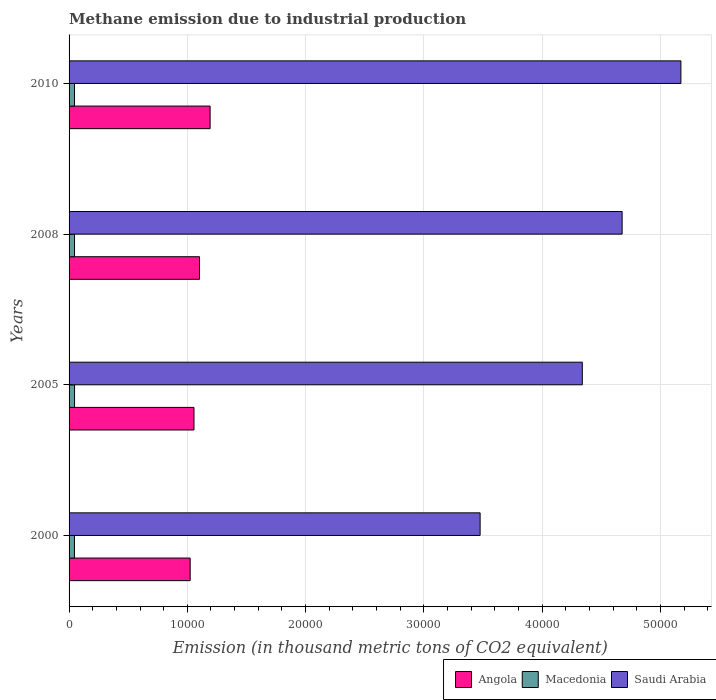How many different coloured bars are there?
Ensure brevity in your answer.  3. Are the number of bars per tick equal to the number of legend labels?
Give a very brief answer. Yes. Are the number of bars on each tick of the Y-axis equal?
Make the answer very short. Yes. What is the amount of methane emitted in Saudi Arabia in 2008?
Your answer should be compact. 4.68e+04. Across all years, what is the maximum amount of methane emitted in Macedonia?
Your answer should be compact. 464.2. Across all years, what is the minimum amount of methane emitted in Angola?
Give a very brief answer. 1.02e+04. In which year was the amount of methane emitted in Saudi Arabia minimum?
Offer a terse response. 2000. What is the total amount of methane emitted in Macedonia in the graph?
Ensure brevity in your answer.  1840.8. What is the difference between the amount of methane emitted in Saudi Arabia in 2000 and that in 2008?
Make the answer very short. -1.20e+04. What is the difference between the amount of methane emitted in Saudi Arabia in 2010 and the amount of methane emitted in Macedonia in 2000?
Provide a short and direct response. 5.13e+04. What is the average amount of methane emitted in Saudi Arabia per year?
Your answer should be very brief. 4.42e+04. In the year 2005, what is the difference between the amount of methane emitted in Angola and amount of methane emitted in Saudi Arabia?
Offer a very short reply. -3.28e+04. What is the ratio of the amount of methane emitted in Angola in 2005 to that in 2010?
Your answer should be very brief. 0.89. Is the difference between the amount of methane emitted in Angola in 2000 and 2008 greater than the difference between the amount of methane emitted in Saudi Arabia in 2000 and 2008?
Offer a terse response. Yes. What is the difference between the highest and the second highest amount of methane emitted in Angola?
Your answer should be compact. 894.1. What is the difference between the highest and the lowest amount of methane emitted in Saudi Arabia?
Provide a succinct answer. 1.70e+04. In how many years, is the amount of methane emitted in Macedonia greater than the average amount of methane emitted in Macedonia taken over all years?
Make the answer very short. 2. What does the 3rd bar from the top in 2005 represents?
Offer a terse response. Angola. What does the 1st bar from the bottom in 2000 represents?
Your answer should be compact. Angola. What is the difference between two consecutive major ticks on the X-axis?
Ensure brevity in your answer.  10000. Does the graph contain any zero values?
Give a very brief answer. No. Does the graph contain grids?
Provide a succinct answer. Yes. Where does the legend appear in the graph?
Keep it short and to the point. Bottom right. How are the legend labels stacked?
Your answer should be compact. Horizontal. What is the title of the graph?
Offer a very short reply. Methane emission due to industrial production. Does "Colombia" appear as one of the legend labels in the graph?
Ensure brevity in your answer.  No. What is the label or title of the X-axis?
Make the answer very short. Emission (in thousand metric tons of CO2 equivalent). What is the Emission (in thousand metric tons of CO2 equivalent) of Angola in 2000?
Offer a very short reply. 1.02e+04. What is the Emission (in thousand metric tons of CO2 equivalent) in Macedonia in 2000?
Your answer should be compact. 454.8. What is the Emission (in thousand metric tons of CO2 equivalent) in Saudi Arabia in 2000?
Offer a very short reply. 3.48e+04. What is the Emission (in thousand metric tons of CO2 equivalent) in Angola in 2005?
Your response must be concise. 1.06e+04. What is the Emission (in thousand metric tons of CO2 equivalent) in Macedonia in 2005?
Your answer should be very brief. 464.2. What is the Emission (in thousand metric tons of CO2 equivalent) in Saudi Arabia in 2005?
Your response must be concise. 4.34e+04. What is the Emission (in thousand metric tons of CO2 equivalent) of Angola in 2008?
Make the answer very short. 1.10e+04. What is the Emission (in thousand metric tons of CO2 equivalent) in Macedonia in 2008?
Your answer should be very brief. 461.8. What is the Emission (in thousand metric tons of CO2 equivalent) in Saudi Arabia in 2008?
Provide a succinct answer. 4.68e+04. What is the Emission (in thousand metric tons of CO2 equivalent) in Angola in 2010?
Offer a very short reply. 1.19e+04. What is the Emission (in thousand metric tons of CO2 equivalent) of Macedonia in 2010?
Make the answer very short. 460. What is the Emission (in thousand metric tons of CO2 equivalent) in Saudi Arabia in 2010?
Your answer should be very brief. 5.17e+04. Across all years, what is the maximum Emission (in thousand metric tons of CO2 equivalent) of Angola?
Give a very brief answer. 1.19e+04. Across all years, what is the maximum Emission (in thousand metric tons of CO2 equivalent) of Macedonia?
Offer a terse response. 464.2. Across all years, what is the maximum Emission (in thousand metric tons of CO2 equivalent) of Saudi Arabia?
Give a very brief answer. 5.17e+04. Across all years, what is the minimum Emission (in thousand metric tons of CO2 equivalent) in Angola?
Your answer should be compact. 1.02e+04. Across all years, what is the minimum Emission (in thousand metric tons of CO2 equivalent) of Macedonia?
Your answer should be very brief. 454.8. Across all years, what is the minimum Emission (in thousand metric tons of CO2 equivalent) in Saudi Arabia?
Give a very brief answer. 3.48e+04. What is the total Emission (in thousand metric tons of CO2 equivalent) in Angola in the graph?
Ensure brevity in your answer.  4.38e+04. What is the total Emission (in thousand metric tons of CO2 equivalent) of Macedonia in the graph?
Keep it short and to the point. 1840.8. What is the total Emission (in thousand metric tons of CO2 equivalent) in Saudi Arabia in the graph?
Your answer should be compact. 1.77e+05. What is the difference between the Emission (in thousand metric tons of CO2 equivalent) in Angola in 2000 and that in 2005?
Offer a very short reply. -321.6. What is the difference between the Emission (in thousand metric tons of CO2 equivalent) of Macedonia in 2000 and that in 2005?
Provide a short and direct response. -9.4. What is the difference between the Emission (in thousand metric tons of CO2 equivalent) of Saudi Arabia in 2000 and that in 2005?
Provide a succinct answer. -8641.3. What is the difference between the Emission (in thousand metric tons of CO2 equivalent) of Angola in 2000 and that in 2008?
Your answer should be compact. -791.1. What is the difference between the Emission (in thousand metric tons of CO2 equivalent) in Saudi Arabia in 2000 and that in 2008?
Provide a short and direct response. -1.20e+04. What is the difference between the Emission (in thousand metric tons of CO2 equivalent) of Angola in 2000 and that in 2010?
Provide a succinct answer. -1685.2. What is the difference between the Emission (in thousand metric tons of CO2 equivalent) in Saudi Arabia in 2000 and that in 2010?
Give a very brief answer. -1.70e+04. What is the difference between the Emission (in thousand metric tons of CO2 equivalent) of Angola in 2005 and that in 2008?
Ensure brevity in your answer.  -469.5. What is the difference between the Emission (in thousand metric tons of CO2 equivalent) of Saudi Arabia in 2005 and that in 2008?
Your answer should be compact. -3365.4. What is the difference between the Emission (in thousand metric tons of CO2 equivalent) of Angola in 2005 and that in 2010?
Your answer should be very brief. -1363.6. What is the difference between the Emission (in thousand metric tons of CO2 equivalent) of Saudi Arabia in 2005 and that in 2010?
Offer a terse response. -8336. What is the difference between the Emission (in thousand metric tons of CO2 equivalent) in Angola in 2008 and that in 2010?
Ensure brevity in your answer.  -894.1. What is the difference between the Emission (in thousand metric tons of CO2 equivalent) in Saudi Arabia in 2008 and that in 2010?
Your answer should be compact. -4970.6. What is the difference between the Emission (in thousand metric tons of CO2 equivalent) of Angola in 2000 and the Emission (in thousand metric tons of CO2 equivalent) of Macedonia in 2005?
Provide a short and direct response. 9776.6. What is the difference between the Emission (in thousand metric tons of CO2 equivalent) in Angola in 2000 and the Emission (in thousand metric tons of CO2 equivalent) in Saudi Arabia in 2005?
Your response must be concise. -3.32e+04. What is the difference between the Emission (in thousand metric tons of CO2 equivalent) in Macedonia in 2000 and the Emission (in thousand metric tons of CO2 equivalent) in Saudi Arabia in 2005?
Give a very brief answer. -4.29e+04. What is the difference between the Emission (in thousand metric tons of CO2 equivalent) in Angola in 2000 and the Emission (in thousand metric tons of CO2 equivalent) in Macedonia in 2008?
Offer a very short reply. 9779. What is the difference between the Emission (in thousand metric tons of CO2 equivalent) in Angola in 2000 and the Emission (in thousand metric tons of CO2 equivalent) in Saudi Arabia in 2008?
Keep it short and to the point. -3.65e+04. What is the difference between the Emission (in thousand metric tons of CO2 equivalent) of Macedonia in 2000 and the Emission (in thousand metric tons of CO2 equivalent) of Saudi Arabia in 2008?
Ensure brevity in your answer.  -4.63e+04. What is the difference between the Emission (in thousand metric tons of CO2 equivalent) of Angola in 2000 and the Emission (in thousand metric tons of CO2 equivalent) of Macedonia in 2010?
Your answer should be very brief. 9780.8. What is the difference between the Emission (in thousand metric tons of CO2 equivalent) of Angola in 2000 and the Emission (in thousand metric tons of CO2 equivalent) of Saudi Arabia in 2010?
Offer a very short reply. -4.15e+04. What is the difference between the Emission (in thousand metric tons of CO2 equivalent) of Macedonia in 2000 and the Emission (in thousand metric tons of CO2 equivalent) of Saudi Arabia in 2010?
Your answer should be compact. -5.13e+04. What is the difference between the Emission (in thousand metric tons of CO2 equivalent) of Angola in 2005 and the Emission (in thousand metric tons of CO2 equivalent) of Macedonia in 2008?
Your response must be concise. 1.01e+04. What is the difference between the Emission (in thousand metric tons of CO2 equivalent) of Angola in 2005 and the Emission (in thousand metric tons of CO2 equivalent) of Saudi Arabia in 2008?
Provide a short and direct response. -3.62e+04. What is the difference between the Emission (in thousand metric tons of CO2 equivalent) in Macedonia in 2005 and the Emission (in thousand metric tons of CO2 equivalent) in Saudi Arabia in 2008?
Your answer should be compact. -4.63e+04. What is the difference between the Emission (in thousand metric tons of CO2 equivalent) of Angola in 2005 and the Emission (in thousand metric tons of CO2 equivalent) of Macedonia in 2010?
Provide a short and direct response. 1.01e+04. What is the difference between the Emission (in thousand metric tons of CO2 equivalent) of Angola in 2005 and the Emission (in thousand metric tons of CO2 equivalent) of Saudi Arabia in 2010?
Offer a terse response. -4.12e+04. What is the difference between the Emission (in thousand metric tons of CO2 equivalent) of Macedonia in 2005 and the Emission (in thousand metric tons of CO2 equivalent) of Saudi Arabia in 2010?
Your answer should be compact. -5.13e+04. What is the difference between the Emission (in thousand metric tons of CO2 equivalent) of Angola in 2008 and the Emission (in thousand metric tons of CO2 equivalent) of Macedonia in 2010?
Make the answer very short. 1.06e+04. What is the difference between the Emission (in thousand metric tons of CO2 equivalent) of Angola in 2008 and the Emission (in thousand metric tons of CO2 equivalent) of Saudi Arabia in 2010?
Make the answer very short. -4.07e+04. What is the difference between the Emission (in thousand metric tons of CO2 equivalent) in Macedonia in 2008 and the Emission (in thousand metric tons of CO2 equivalent) in Saudi Arabia in 2010?
Keep it short and to the point. -5.13e+04. What is the average Emission (in thousand metric tons of CO2 equivalent) of Angola per year?
Provide a succinct answer. 1.09e+04. What is the average Emission (in thousand metric tons of CO2 equivalent) of Macedonia per year?
Offer a terse response. 460.2. What is the average Emission (in thousand metric tons of CO2 equivalent) in Saudi Arabia per year?
Offer a very short reply. 4.42e+04. In the year 2000, what is the difference between the Emission (in thousand metric tons of CO2 equivalent) in Angola and Emission (in thousand metric tons of CO2 equivalent) in Macedonia?
Ensure brevity in your answer.  9786. In the year 2000, what is the difference between the Emission (in thousand metric tons of CO2 equivalent) of Angola and Emission (in thousand metric tons of CO2 equivalent) of Saudi Arabia?
Offer a terse response. -2.45e+04. In the year 2000, what is the difference between the Emission (in thousand metric tons of CO2 equivalent) in Macedonia and Emission (in thousand metric tons of CO2 equivalent) in Saudi Arabia?
Offer a terse response. -3.43e+04. In the year 2005, what is the difference between the Emission (in thousand metric tons of CO2 equivalent) in Angola and Emission (in thousand metric tons of CO2 equivalent) in Macedonia?
Your answer should be compact. 1.01e+04. In the year 2005, what is the difference between the Emission (in thousand metric tons of CO2 equivalent) of Angola and Emission (in thousand metric tons of CO2 equivalent) of Saudi Arabia?
Make the answer very short. -3.28e+04. In the year 2005, what is the difference between the Emission (in thousand metric tons of CO2 equivalent) in Macedonia and Emission (in thousand metric tons of CO2 equivalent) in Saudi Arabia?
Your response must be concise. -4.29e+04. In the year 2008, what is the difference between the Emission (in thousand metric tons of CO2 equivalent) of Angola and Emission (in thousand metric tons of CO2 equivalent) of Macedonia?
Provide a succinct answer. 1.06e+04. In the year 2008, what is the difference between the Emission (in thousand metric tons of CO2 equivalent) of Angola and Emission (in thousand metric tons of CO2 equivalent) of Saudi Arabia?
Offer a terse response. -3.57e+04. In the year 2008, what is the difference between the Emission (in thousand metric tons of CO2 equivalent) of Macedonia and Emission (in thousand metric tons of CO2 equivalent) of Saudi Arabia?
Offer a terse response. -4.63e+04. In the year 2010, what is the difference between the Emission (in thousand metric tons of CO2 equivalent) in Angola and Emission (in thousand metric tons of CO2 equivalent) in Macedonia?
Ensure brevity in your answer.  1.15e+04. In the year 2010, what is the difference between the Emission (in thousand metric tons of CO2 equivalent) of Angola and Emission (in thousand metric tons of CO2 equivalent) of Saudi Arabia?
Offer a very short reply. -3.98e+04. In the year 2010, what is the difference between the Emission (in thousand metric tons of CO2 equivalent) of Macedonia and Emission (in thousand metric tons of CO2 equivalent) of Saudi Arabia?
Make the answer very short. -5.13e+04. What is the ratio of the Emission (in thousand metric tons of CO2 equivalent) in Angola in 2000 to that in 2005?
Keep it short and to the point. 0.97. What is the ratio of the Emission (in thousand metric tons of CO2 equivalent) in Macedonia in 2000 to that in 2005?
Your answer should be very brief. 0.98. What is the ratio of the Emission (in thousand metric tons of CO2 equivalent) in Saudi Arabia in 2000 to that in 2005?
Your answer should be compact. 0.8. What is the ratio of the Emission (in thousand metric tons of CO2 equivalent) of Angola in 2000 to that in 2008?
Offer a terse response. 0.93. What is the ratio of the Emission (in thousand metric tons of CO2 equivalent) in Macedonia in 2000 to that in 2008?
Your response must be concise. 0.98. What is the ratio of the Emission (in thousand metric tons of CO2 equivalent) of Saudi Arabia in 2000 to that in 2008?
Provide a short and direct response. 0.74. What is the ratio of the Emission (in thousand metric tons of CO2 equivalent) of Angola in 2000 to that in 2010?
Make the answer very short. 0.86. What is the ratio of the Emission (in thousand metric tons of CO2 equivalent) of Macedonia in 2000 to that in 2010?
Offer a very short reply. 0.99. What is the ratio of the Emission (in thousand metric tons of CO2 equivalent) in Saudi Arabia in 2000 to that in 2010?
Your answer should be compact. 0.67. What is the ratio of the Emission (in thousand metric tons of CO2 equivalent) of Angola in 2005 to that in 2008?
Provide a succinct answer. 0.96. What is the ratio of the Emission (in thousand metric tons of CO2 equivalent) of Macedonia in 2005 to that in 2008?
Your answer should be very brief. 1.01. What is the ratio of the Emission (in thousand metric tons of CO2 equivalent) of Saudi Arabia in 2005 to that in 2008?
Give a very brief answer. 0.93. What is the ratio of the Emission (in thousand metric tons of CO2 equivalent) of Angola in 2005 to that in 2010?
Provide a succinct answer. 0.89. What is the ratio of the Emission (in thousand metric tons of CO2 equivalent) of Macedonia in 2005 to that in 2010?
Make the answer very short. 1.01. What is the ratio of the Emission (in thousand metric tons of CO2 equivalent) of Saudi Arabia in 2005 to that in 2010?
Make the answer very short. 0.84. What is the ratio of the Emission (in thousand metric tons of CO2 equivalent) of Angola in 2008 to that in 2010?
Your answer should be very brief. 0.93. What is the ratio of the Emission (in thousand metric tons of CO2 equivalent) of Macedonia in 2008 to that in 2010?
Keep it short and to the point. 1. What is the ratio of the Emission (in thousand metric tons of CO2 equivalent) of Saudi Arabia in 2008 to that in 2010?
Provide a succinct answer. 0.9. What is the difference between the highest and the second highest Emission (in thousand metric tons of CO2 equivalent) of Angola?
Offer a very short reply. 894.1. What is the difference between the highest and the second highest Emission (in thousand metric tons of CO2 equivalent) of Macedonia?
Offer a terse response. 2.4. What is the difference between the highest and the second highest Emission (in thousand metric tons of CO2 equivalent) of Saudi Arabia?
Ensure brevity in your answer.  4970.6. What is the difference between the highest and the lowest Emission (in thousand metric tons of CO2 equivalent) of Angola?
Make the answer very short. 1685.2. What is the difference between the highest and the lowest Emission (in thousand metric tons of CO2 equivalent) in Saudi Arabia?
Keep it short and to the point. 1.70e+04. 